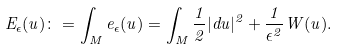Convert formula to latex. <formula><loc_0><loc_0><loc_500><loc_500>E _ { \epsilon } ( u ) \colon = \int _ { M } e _ { \epsilon } ( u ) = \int _ { M } \frac { 1 } { 2 } | d u | ^ { 2 } + \frac { 1 } { \epsilon ^ { 2 } } W ( u ) .</formula> 